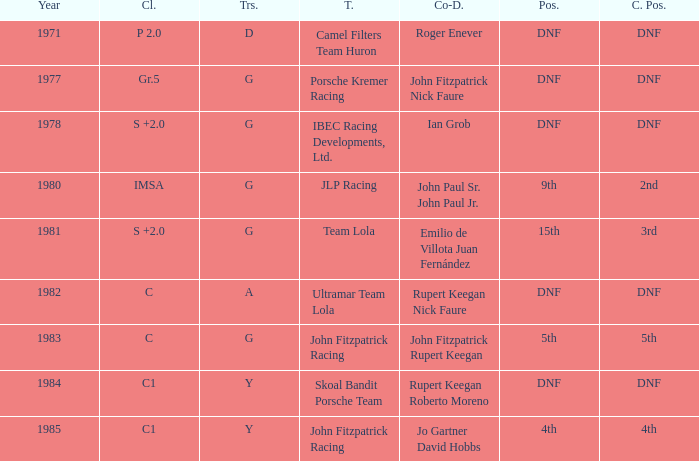Who was the co-driver that had a class position of 2nd? John Paul Sr. John Paul Jr. 